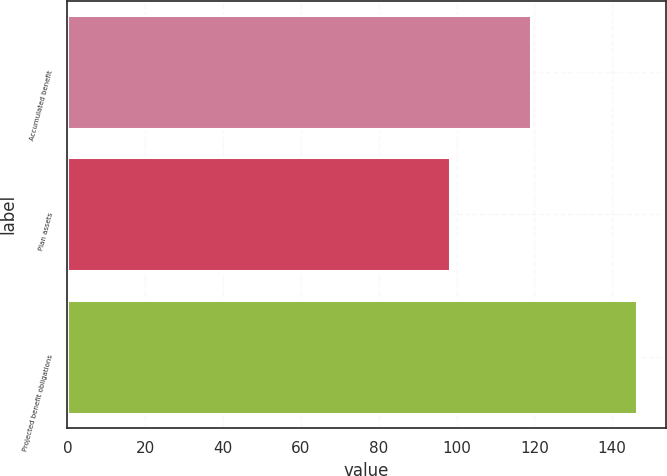<chart> <loc_0><loc_0><loc_500><loc_500><bar_chart><fcel>Accumulated benefit<fcel>Plan assets<fcel>Projected benefit obligations<nl><fcel>119.2<fcel>98.3<fcel>146.4<nl></chart> 